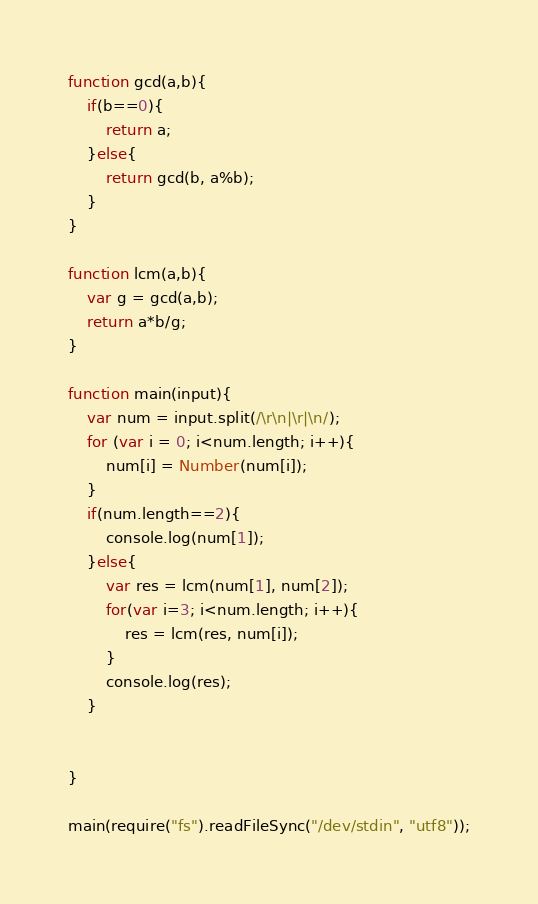Convert code to text. <code><loc_0><loc_0><loc_500><loc_500><_JavaScript_>function gcd(a,b){
    if(b==0){
        return a;
    }else{
        return gcd(b, a%b);
    }
}

function lcm(a,b){
    var g = gcd(a,b);
    return a*b/g;
}

function main(input){
    var num = input.split(/\r\n|\r|\n/);
    for (var i = 0; i<num.length; i++){
        num[i] = Number(num[i]);
    }
    if(num.length==2){
        console.log(num[1]);
    }else{
        var res = lcm(num[1], num[2]);
        for(var i=3; i<num.length; i++){
            res = lcm(res, num[i]);
        }
        console.log(res);
    }


}

main(require("fs").readFileSync("/dev/stdin", "utf8"));</code> 